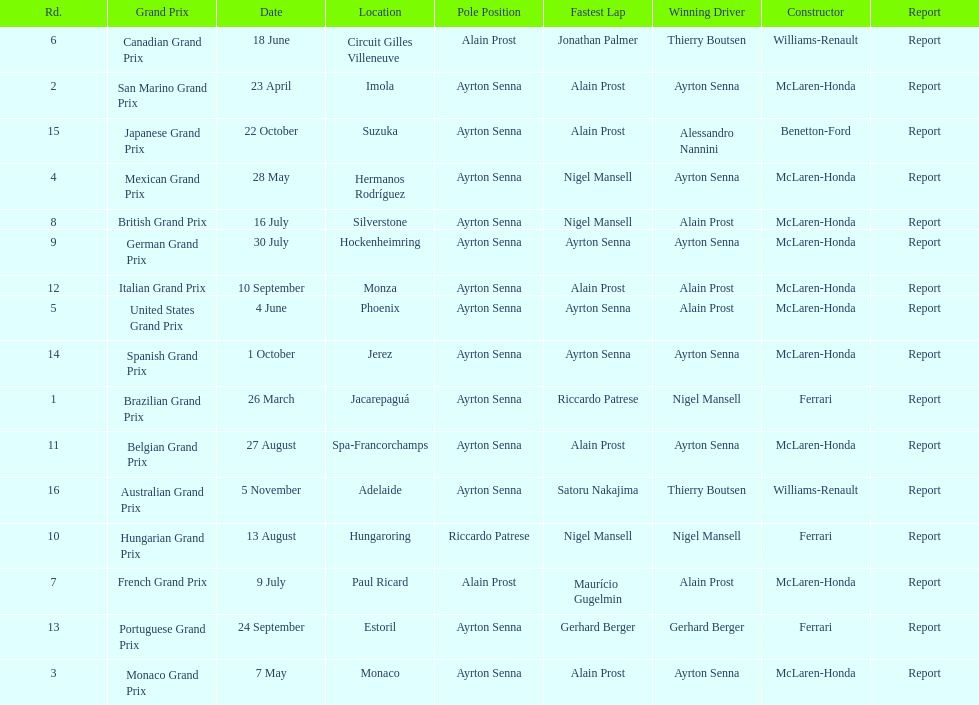Prost won the drivers title, who was his teammate? Ayrton Senna. 